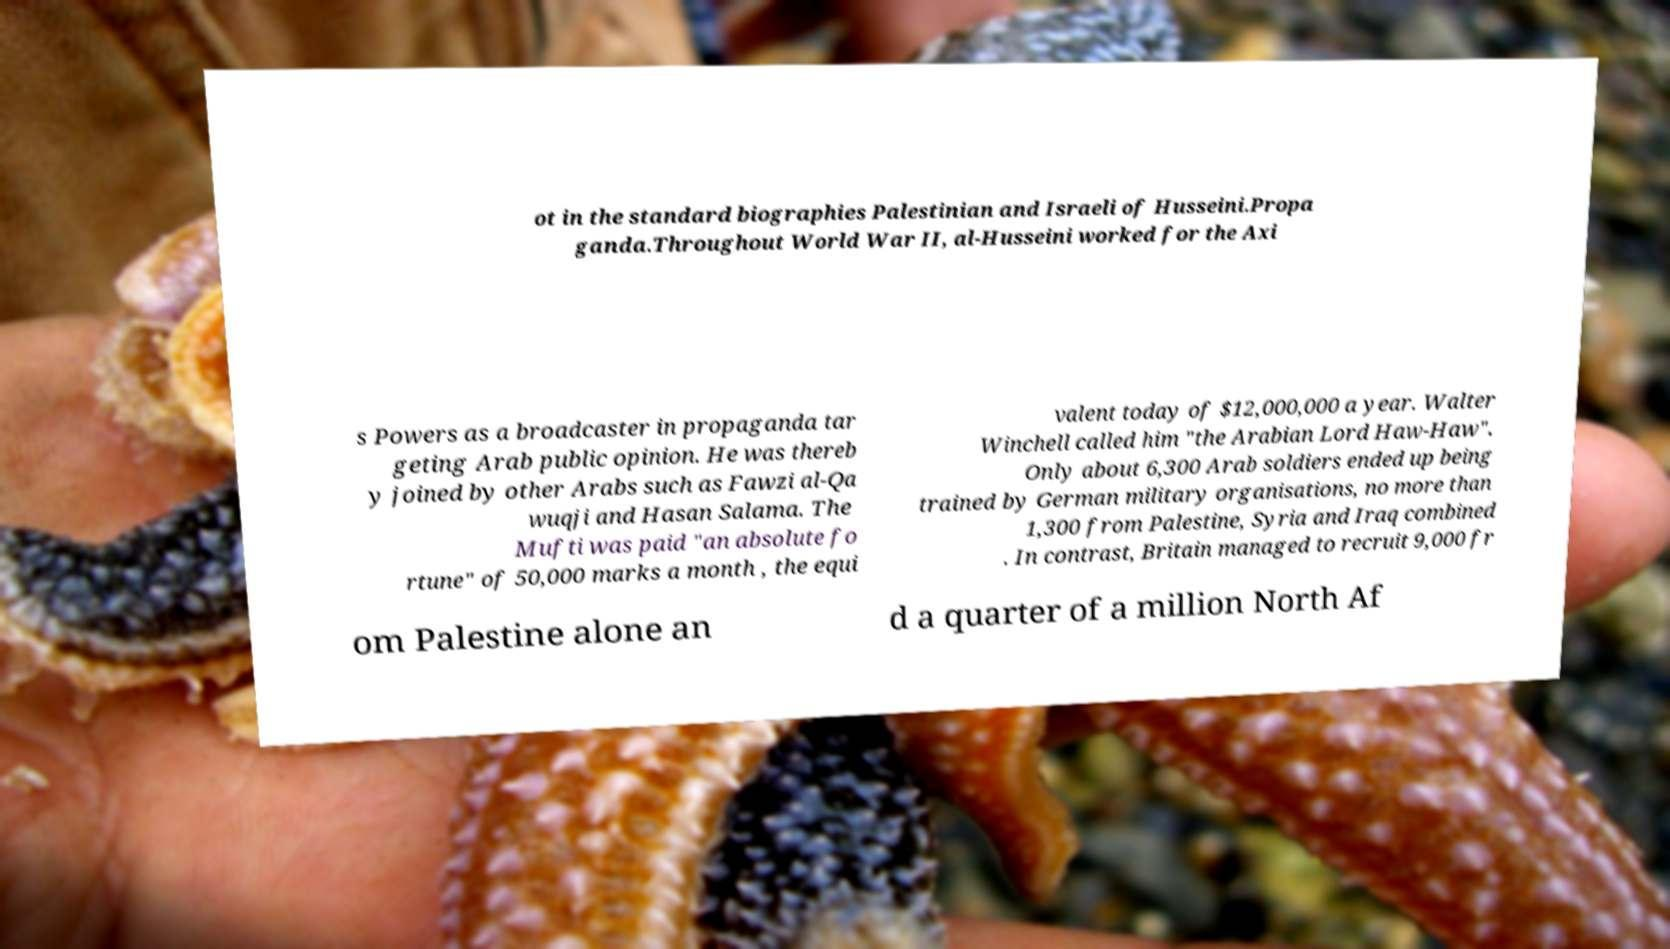What messages or text are displayed in this image? I need them in a readable, typed format. ot in the standard biographies Palestinian and Israeli of Husseini.Propa ganda.Throughout World War II, al-Husseini worked for the Axi s Powers as a broadcaster in propaganda tar geting Arab public opinion. He was thereb y joined by other Arabs such as Fawzi al-Qa wuqji and Hasan Salama. The Mufti was paid "an absolute fo rtune" of 50,000 marks a month , the equi valent today of $12,000,000 a year. Walter Winchell called him "the Arabian Lord Haw-Haw". Only about 6,300 Arab soldiers ended up being trained by German military organisations, no more than 1,300 from Palestine, Syria and Iraq combined . In contrast, Britain managed to recruit 9,000 fr om Palestine alone an d a quarter of a million North Af 